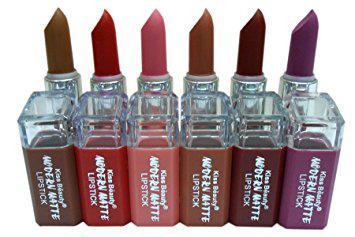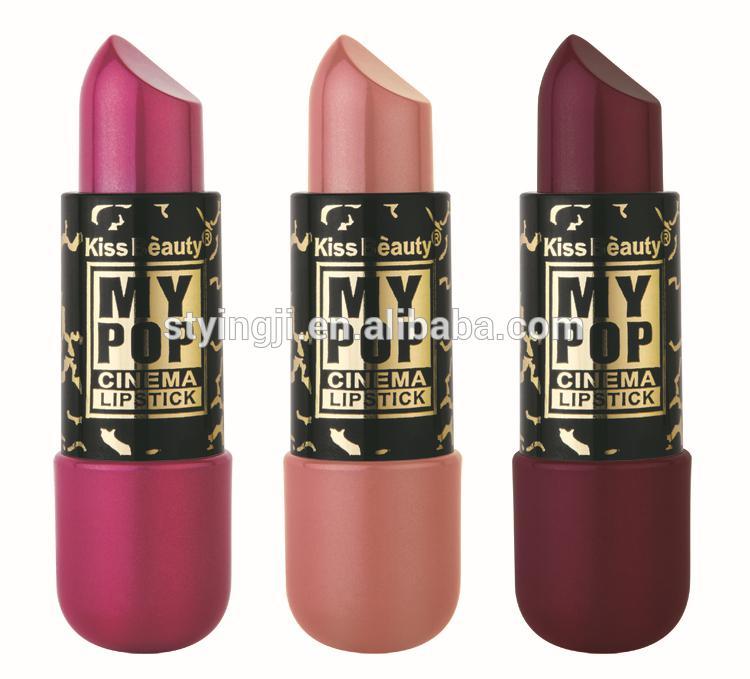The first image is the image on the left, the second image is the image on the right. Assess this claim about the two images: "Each image in the pair shows the same number of uncapped lipsticks.". Correct or not? Answer yes or no. No. 